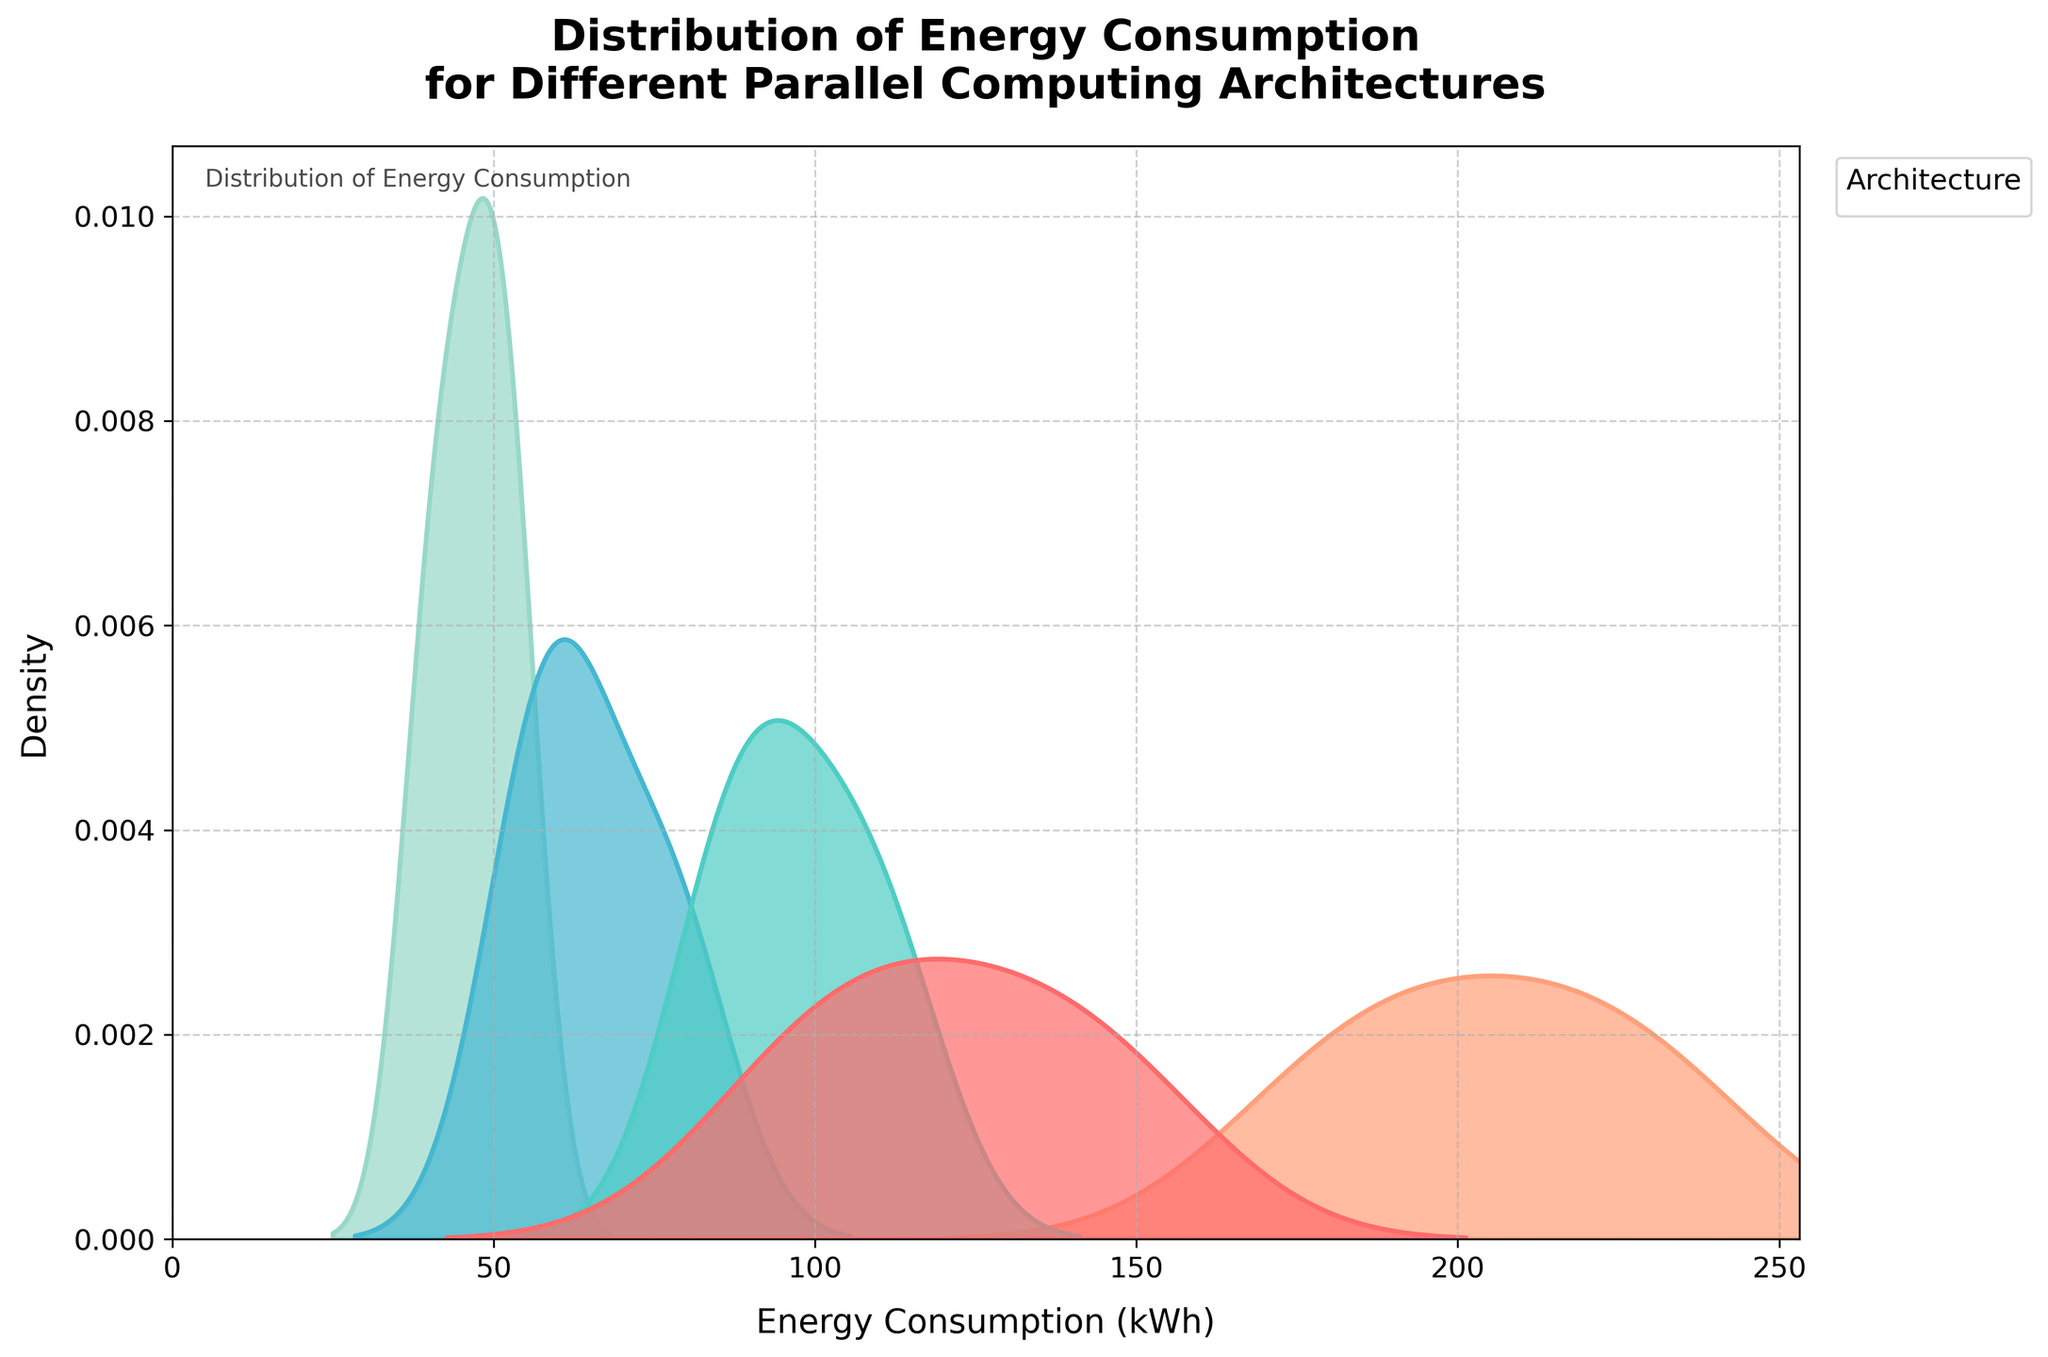What is the peak density of energy consumption for the Quantum Computer architecture? The peak density is the highest point on the density curve for Quantum Computer architecture. By looking at the plot, locate the highest point of the Quantum Computer's curve.
Answer: The peak density Which architecture has the lowest average energy consumption? To determine the architecture with the lowest average energy consumption, visually inspect the density plots and identify which curve's central region (mean) is the furthest to the left on the x-axis.
Answer: Neuromorphic Chip How many different architectures are compared in the plot? Count the distinct number of density curves, as each represents a different architecture.
Answer: Four Which architecture shows the widest spread of energy consumption values? Look for the architecture with the flattest and widest density curve, indicating a broader distribution of energy consumption values.
Answer: Quantum Computer Is the distribution of energy consumption for the CPU Cluster architecture skewed towards higher or lower values? Determine the skewness by observing where the density curve has its peak relative to the overall spread. If the peak is on the left, it is skewed towards higher values, and vice-versa.
Answer: Higher values Between GPU Cluster and FPGA Array, which architecture has a more concentrated energy consumption distribution? Compare the density curves of GPU Cluster and FPGA Array. The more concentrated one will have a sharper peak.
Answer: FPGA Array What is the approximate range of energy consumption values for the Neuromorphic Chip architecture? Identify the start and end points of the Neuromorphic Chip's density curve along the x-axis to estimate the range.
Answer: Approximately 40 to 55 kWh Which architecture has the highest energy consumption value captured in the density plot? Identify the rightmost point on the x-axis across all the density curves.
Answer: Quantum Computer Can we say that GPU Cluster has lower energy consumption compared to CPU Cluster for the workloads shown? Compare the density curves of GPU Cluster and CPU Cluster to see if GPU Cluster's curve is generally to the left of CPU Cluster's curve.
Answer: Yes 